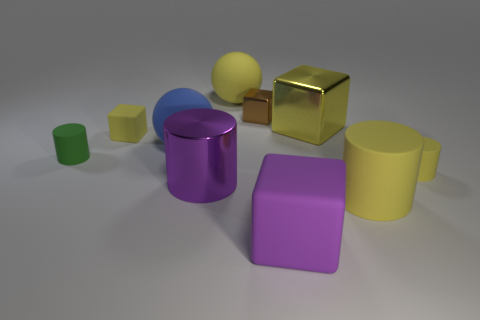Subtract all cubes. How many objects are left? 6 Add 1 small green cylinders. How many small green cylinders exist? 2 Subtract 1 blue spheres. How many objects are left? 9 Subtract all large yellow metallic cubes. Subtract all tiny yellow cubes. How many objects are left? 8 Add 5 metal blocks. How many metal blocks are left? 7 